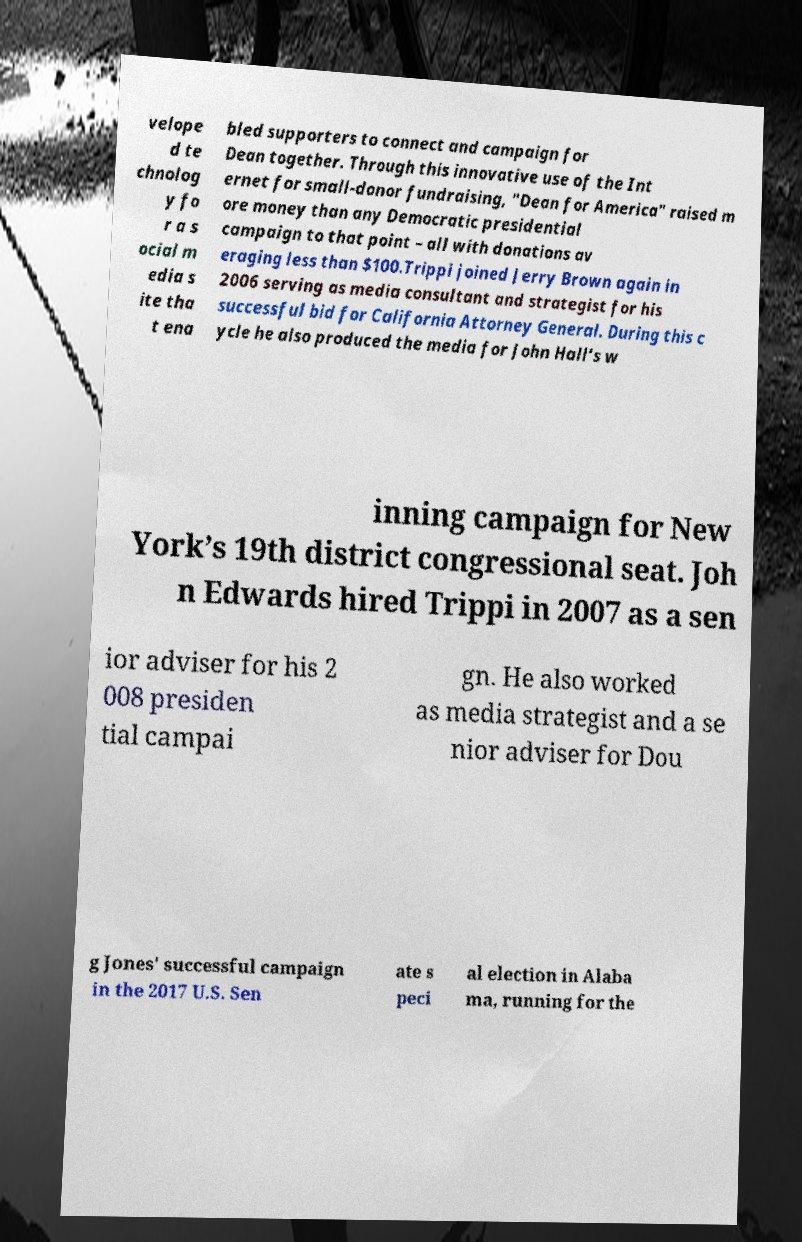Could you assist in decoding the text presented in this image and type it out clearly? velope d te chnolog y fo r a s ocial m edia s ite tha t ena bled supporters to connect and campaign for Dean together. Through this innovative use of the Int ernet for small-donor fundraising, "Dean for America" raised m ore money than any Democratic presidential campaign to that point – all with donations av eraging less than $100.Trippi joined Jerry Brown again in 2006 serving as media consultant and strategist for his successful bid for California Attorney General. During this c ycle he also produced the media for John Hall’s w inning campaign for New York’s 19th district congressional seat. Joh n Edwards hired Trippi in 2007 as a sen ior adviser for his 2 008 presiden tial campai gn. He also worked as media strategist and a se nior adviser for Dou g Jones' successful campaign in the 2017 U.S. Sen ate s peci al election in Alaba ma, running for the 